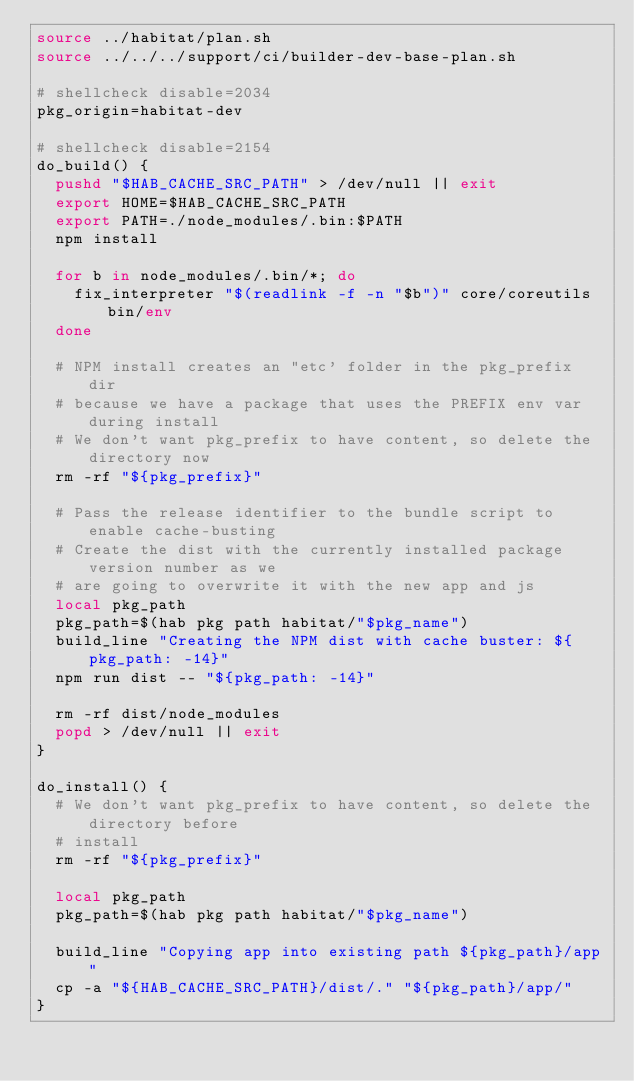Convert code to text. <code><loc_0><loc_0><loc_500><loc_500><_Bash_>source ../habitat/plan.sh
source ../../../support/ci/builder-dev-base-plan.sh

# shellcheck disable=2034
pkg_origin=habitat-dev

# shellcheck disable=2154
do_build() {
  pushd "$HAB_CACHE_SRC_PATH" > /dev/null || exit
  export HOME=$HAB_CACHE_SRC_PATH
  export PATH=./node_modules/.bin:$PATH
  npm install

  for b in node_modules/.bin/*; do
    fix_interpreter "$(readlink -f -n "$b")" core/coreutils bin/env
  done

  # NPM install creates an "etc' folder in the pkg_prefix dir
  # because we have a package that uses the PREFIX env var during install
  # We don't want pkg_prefix to have content, so delete the directory now
  rm -rf "${pkg_prefix}"

  # Pass the release identifier to the bundle script to enable cache-busting
  # Create the dist with the currently installed package version number as we
  # are going to overwrite it with the new app and js
  local pkg_path
  pkg_path=$(hab pkg path habitat/"$pkg_name")
  build_line "Creating the NPM dist with cache buster: ${pkg_path: -14}"
  npm run dist -- "${pkg_path: -14}"

  rm -rf dist/node_modules
  popd > /dev/null || exit
}

do_install() {
  # We don't want pkg_prefix to have content, so delete the directory before
  # install
  rm -rf "${pkg_prefix}"

  local pkg_path
  pkg_path=$(hab pkg path habitat/"$pkg_name")

  build_line "Copying app into existing path ${pkg_path}/app"
  cp -a "${HAB_CACHE_SRC_PATH}/dist/." "${pkg_path}/app/"
}
</code> 